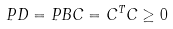Convert formula to latex. <formula><loc_0><loc_0><loc_500><loc_500>P D = P B C = C ^ { T } C \geq 0</formula> 